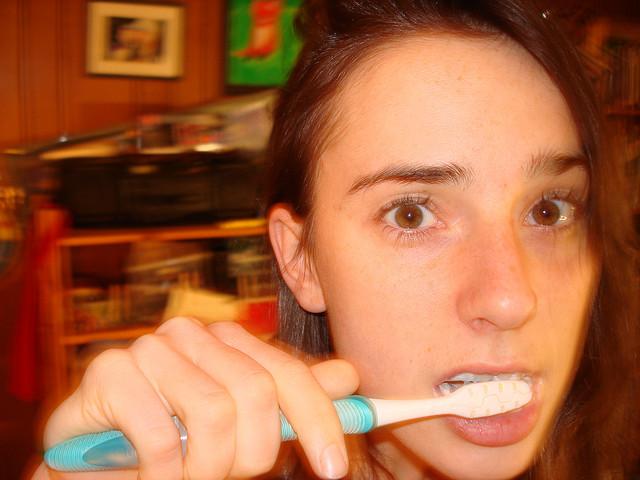What is this lady doing?
Short answer required. Brushing teeth. Where is the picture frame?
Answer briefly. On wall. Is this woman looking at the camera?
Write a very short answer. Yes. 